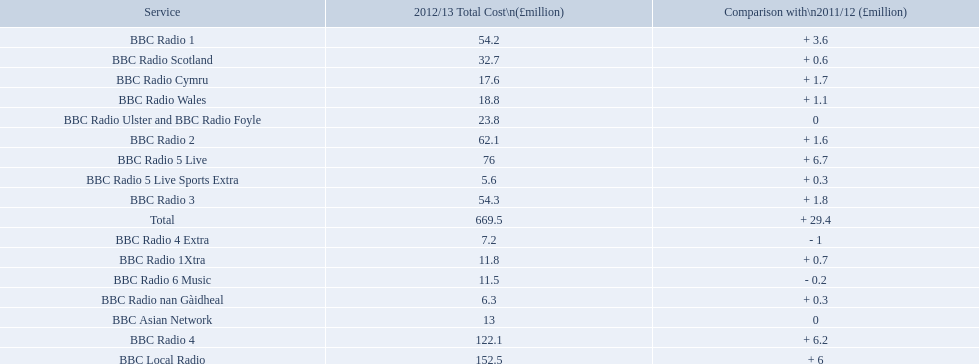What are the bbc stations? BBC Radio 1, BBC Radio 1Xtra, BBC Radio 2, BBC Radio 3, BBC Radio 4, BBC Radio 4 Extra, BBC Radio 5 Live, BBC Radio 5 Live Sports Extra, BBC Radio 6 Music, BBC Asian Network, BBC Local Radio, BBC Radio Scotland, BBC Radio nan Gàidheal, BBC Radio Wales, BBC Radio Cymru, BBC Radio Ulster and BBC Radio Foyle. What was the highest cost to run out of all? 122.1. Which one cost this? BBC Local Radio. Help me parse the entirety of this table. {'header': ['Service', '2012/13 Total Cost\\n(£million)', 'Comparison with\\n2011/12 (£million)'], 'rows': [['BBC Radio 1', '54.2', '+ 3.6'], ['BBC Radio Scotland', '32.7', '+ 0.6'], ['BBC Radio Cymru', '17.6', '+ 1.7'], ['BBC Radio Wales', '18.8', '+ 1.1'], ['BBC Radio Ulster and BBC Radio Foyle', '23.8', '0'], ['BBC Radio 2', '62.1', '+ 1.6'], ['BBC Radio 5 Live', '76', '+ 6.7'], ['BBC Radio 5 Live Sports Extra', '5.6', '+ 0.3'], ['BBC Radio 3', '54.3', '+ 1.8'], ['Total', '669.5', '+ 29.4'], ['BBC Radio 4 Extra', '7.2', '- 1'], ['BBC Radio 1Xtra', '11.8', '+ 0.7'], ['BBC Radio 6 Music', '11.5', '- 0.2'], ['BBC Radio nan Gàidheal', '6.3', '+ 0.3'], ['BBC Asian Network', '13', '0'], ['BBC Radio 4', '122.1', '+ 6.2'], ['BBC Local Radio', '152.5', '+ 6']]} 